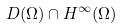Convert formula to latex. <formula><loc_0><loc_0><loc_500><loc_500>D ( \Omega ) \cap H ^ { \infty } ( \Omega )</formula> 